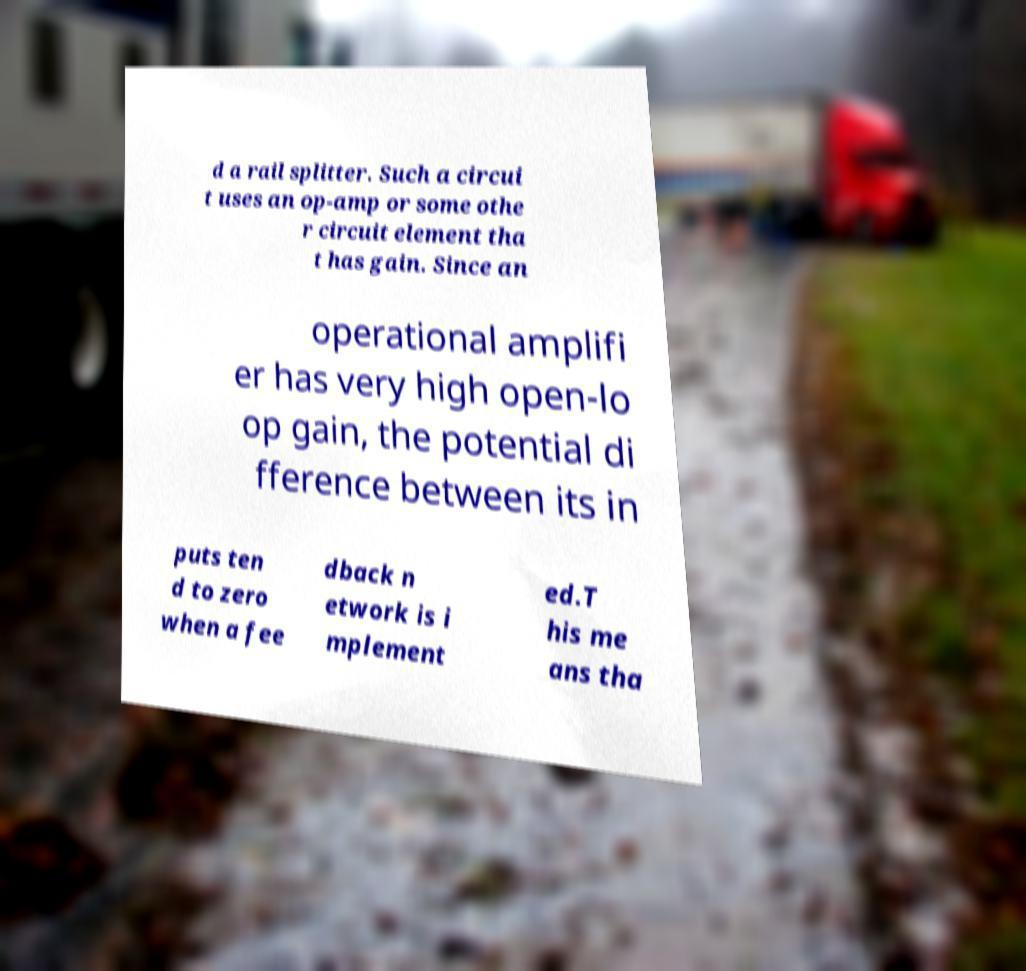Please identify and transcribe the text found in this image. d a rail splitter. Such a circui t uses an op-amp or some othe r circuit element tha t has gain. Since an operational amplifi er has very high open-lo op gain, the potential di fference between its in puts ten d to zero when a fee dback n etwork is i mplement ed.T his me ans tha 